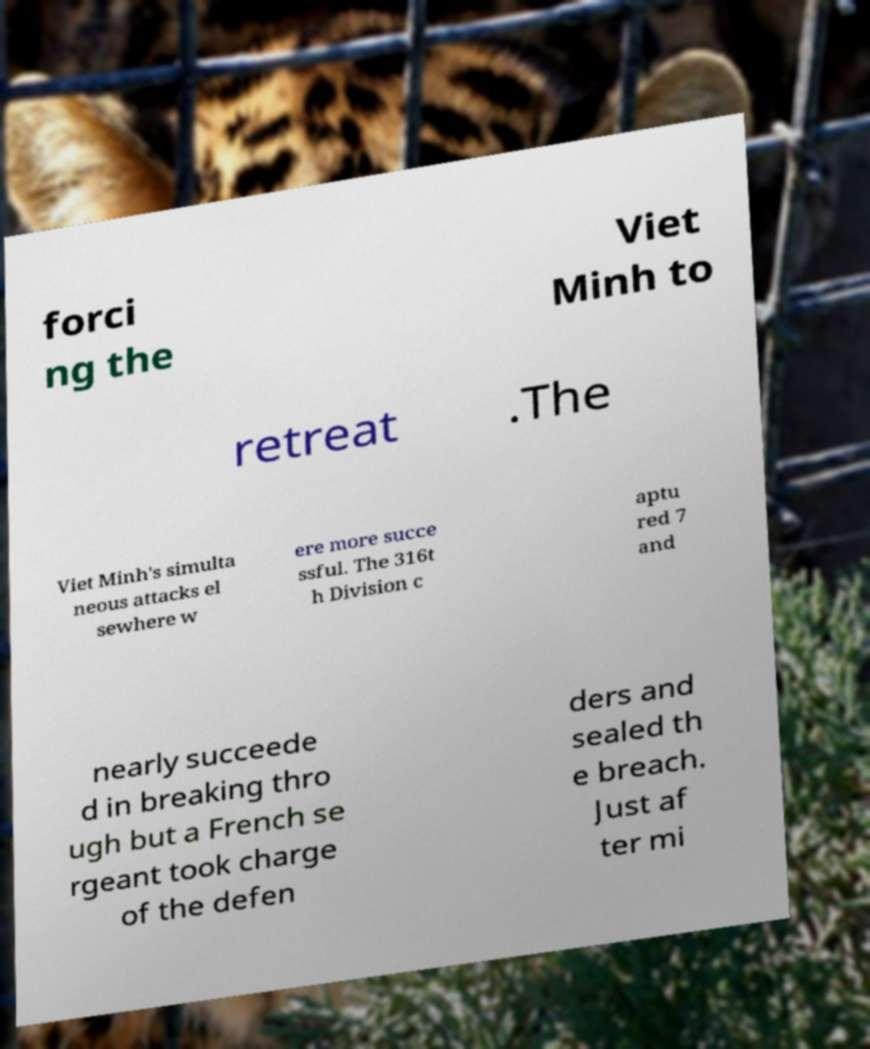Could you extract and type out the text from this image? forci ng the Viet Minh to retreat .The Viet Minh's simulta neous attacks el sewhere w ere more succe ssful. The 316t h Division c aptu red 7 and nearly succeede d in breaking thro ugh but a French se rgeant took charge of the defen ders and sealed th e breach. Just af ter mi 